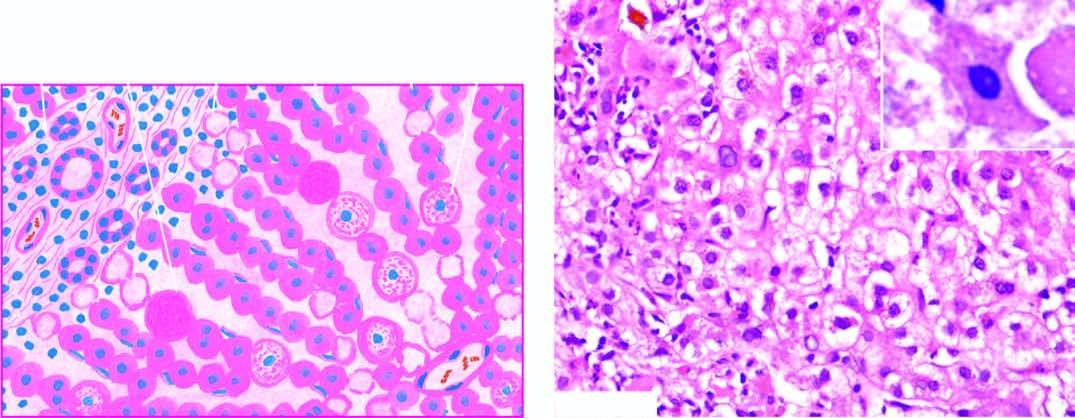re the tiny silica particles indicative of more severe liver cell injury?
Answer the question using a single word or phrase. No 